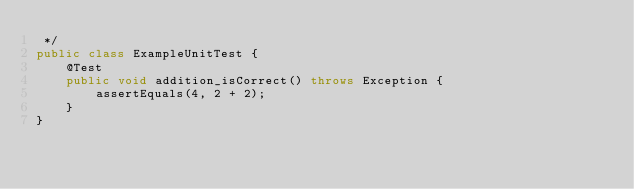Convert code to text. <code><loc_0><loc_0><loc_500><loc_500><_Java_> */
public class ExampleUnitTest {
    @Test
    public void addition_isCorrect() throws Exception {
        assertEquals(4, 2 + 2);
    }
}</code> 